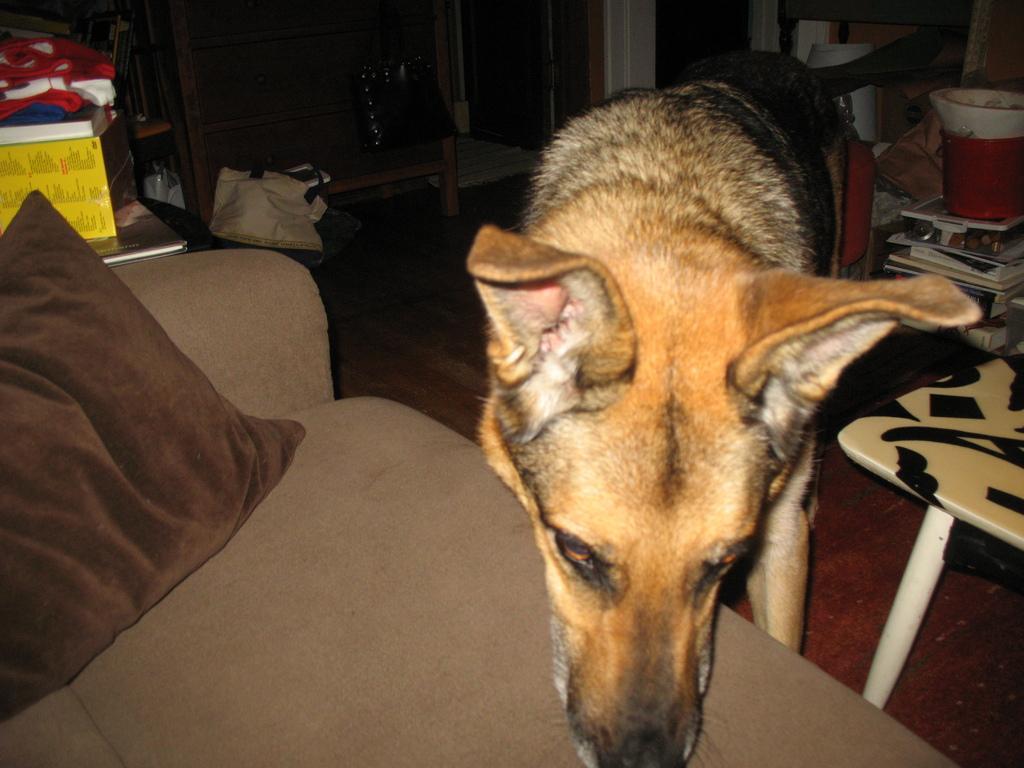Describe this image in one or two sentences. In this image we can see a dog, sofa, pillow. In the background of the image there is door. To the right side of the image there is a table. There are books. At the bottom of the image there is wooden flooring. To the left side of the image there are objects. 